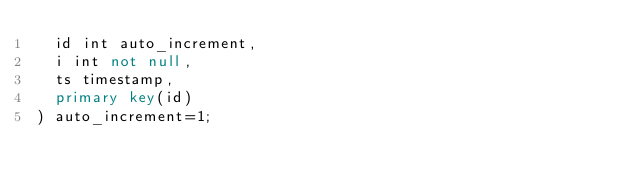Convert code to text. <code><loc_0><loc_0><loc_500><loc_500><_SQL_>  id int auto_increment,
  i int not null,
  ts timestamp,
  primary key(id)
) auto_increment=1;
</code> 